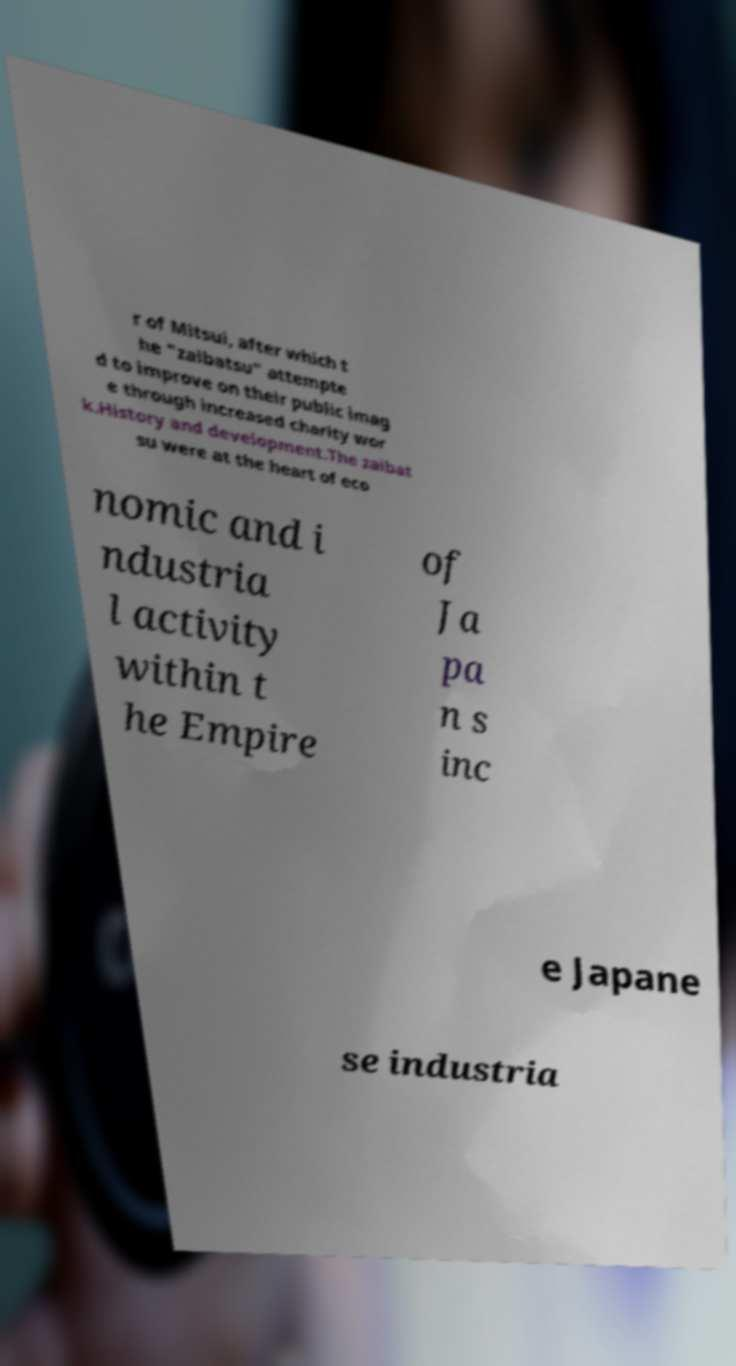Please identify and transcribe the text found in this image. r of Mitsui, after which t he "zaibatsu" attempte d to improve on their public imag e through increased charity wor k.History and development.The zaibat su were at the heart of eco nomic and i ndustria l activity within t he Empire of Ja pa n s inc e Japane se industria 